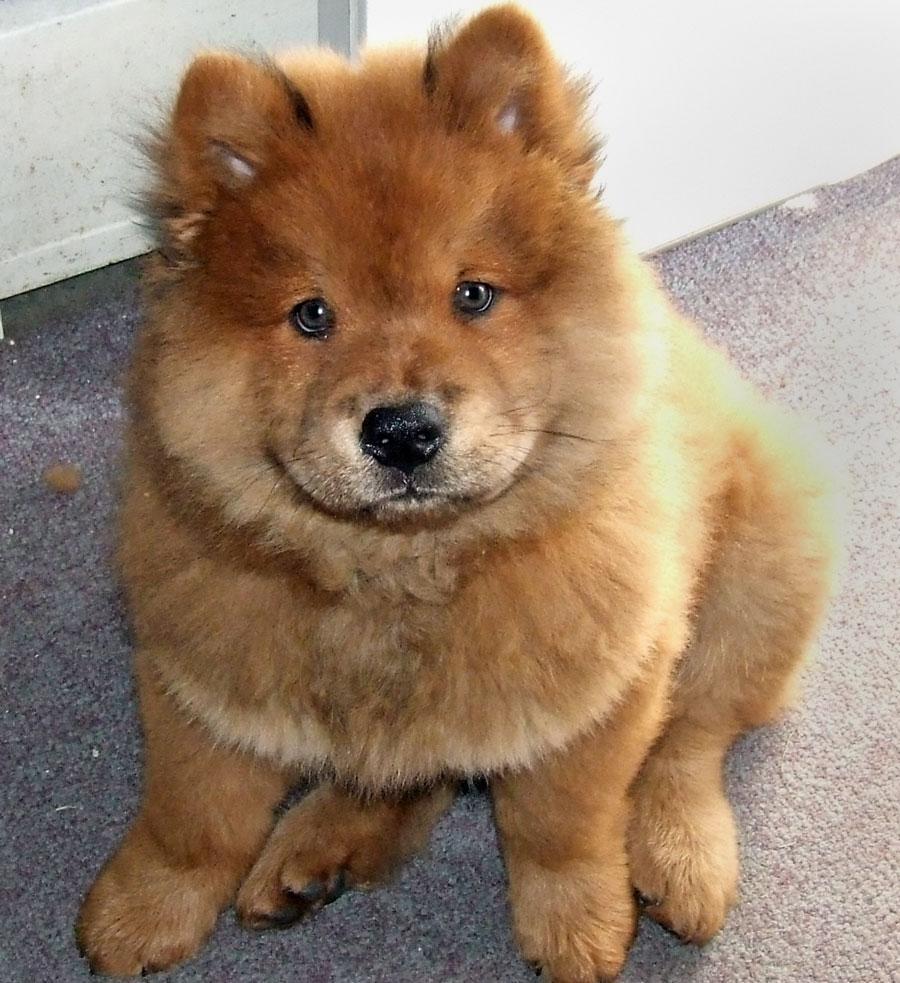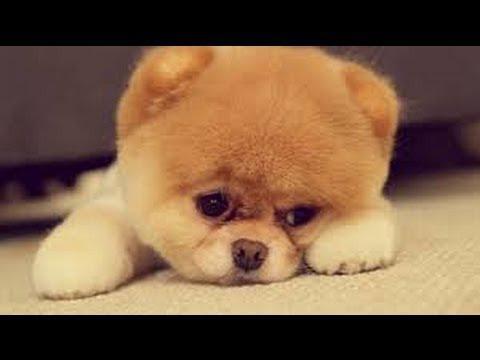The first image is the image on the left, the second image is the image on the right. For the images displayed, is the sentence "At least one of the dogs is being handled by a human; either by leash or by grip." factually correct? Answer yes or no. No. 